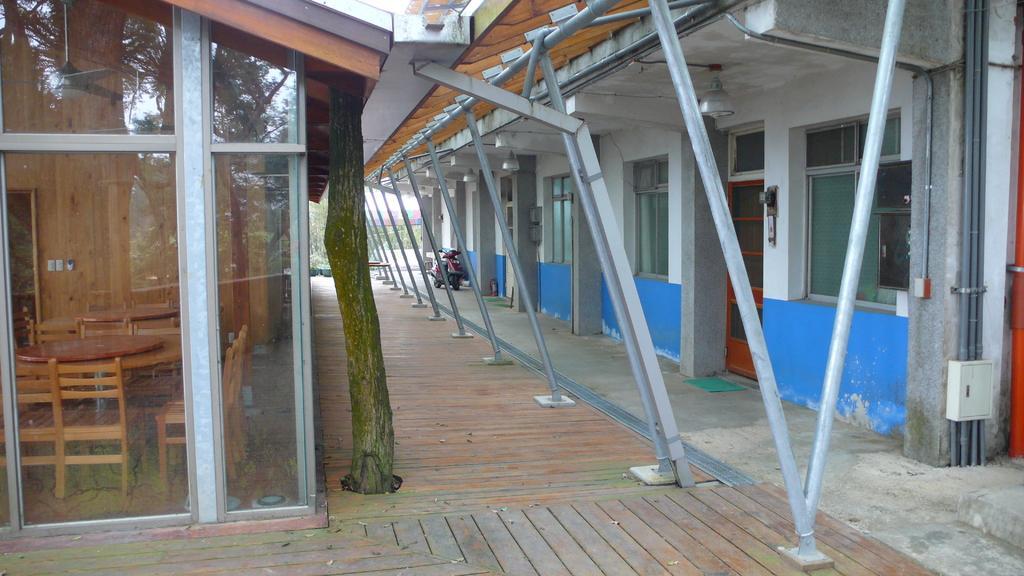In one or two sentences, can you explain what this image depicts? On the left of the image there are tables and chairs and a ceiling fan in a glass room, beside the glass room there is a tree, on the right side of the image there are doors and windows of a building, in front of them on the corridor there is a bike parked and there are metal poles on the corridor, in the corner of the image there are pipes and electrical box on the wall. 